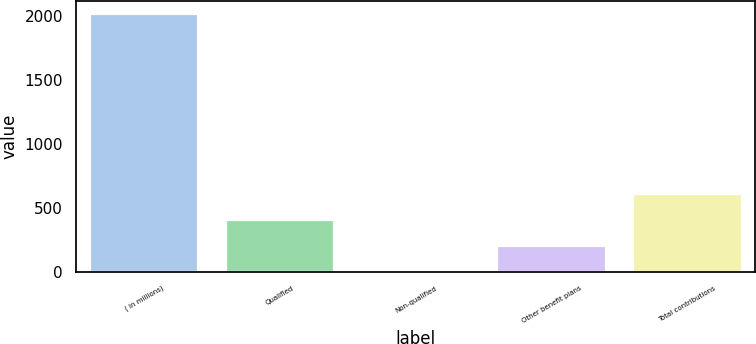Convert chart. <chart><loc_0><loc_0><loc_500><loc_500><bar_chart><fcel>( in millions)<fcel>Qualified<fcel>Non-qualified<fcel>Other benefit plans<fcel>Total contributions<nl><fcel>2013<fcel>405.8<fcel>4<fcel>204.9<fcel>606.7<nl></chart> 